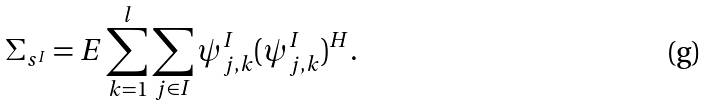Convert formula to latex. <formula><loc_0><loc_0><loc_500><loc_500>\Sigma _ { s ^ { I } } & = E \sum _ { k = 1 } ^ { l } \sum _ { j \in I } \psi ^ { I } _ { j , k } ( \psi ^ { I } _ { j , k } ) ^ { H } .</formula> 